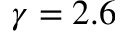<formula> <loc_0><loc_0><loc_500><loc_500>\gamma = 2 . 6</formula> 